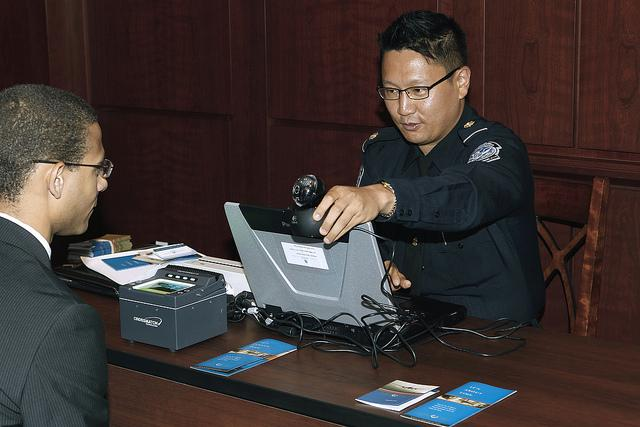What is the person with the laptop taking?

Choices:
A) dictation
B) photograph
C) autographs
D) memo photograph 